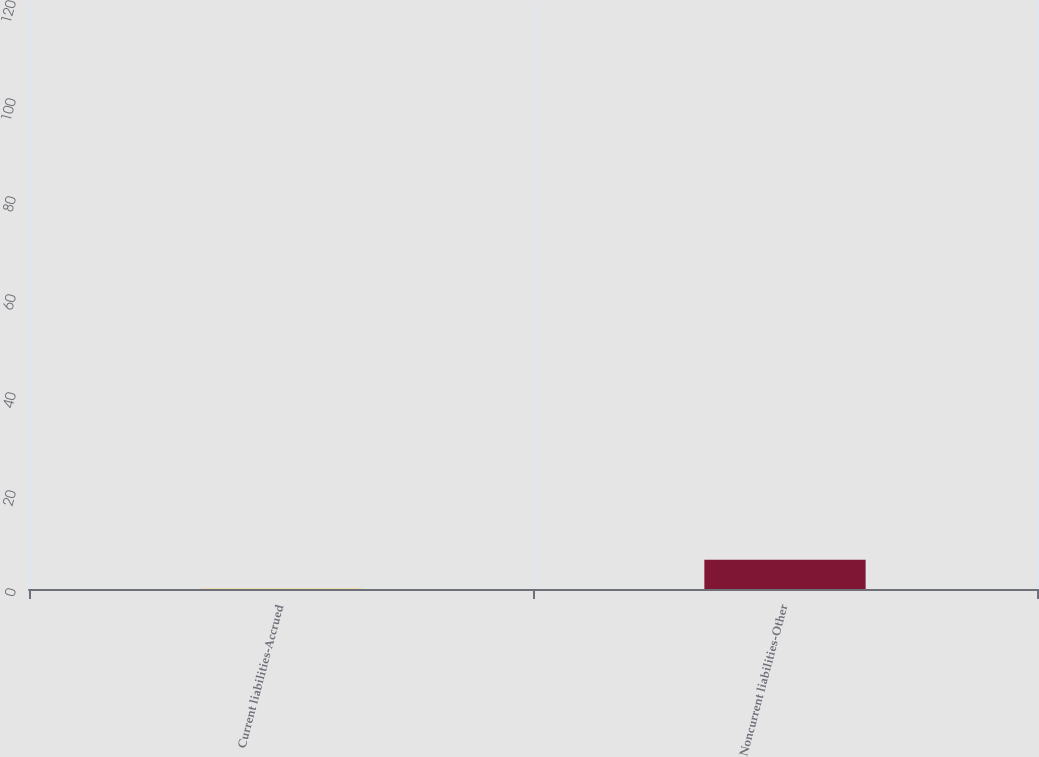<chart> <loc_0><loc_0><loc_500><loc_500><bar_chart><fcel>Current liabilities-Accrued<fcel>Noncurrent liabilities-Other<nl><fcel>1<fcel>106.7<nl></chart> 